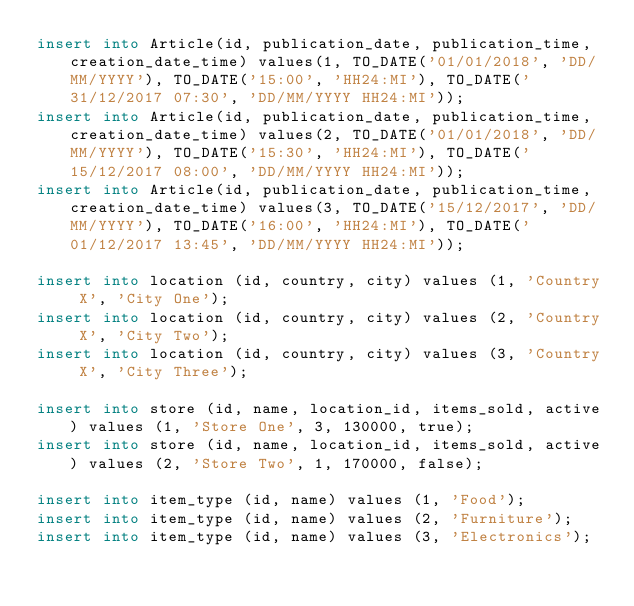<code> <loc_0><loc_0><loc_500><loc_500><_SQL_>insert into Article(id, publication_date, publication_time, creation_date_time) values(1, TO_DATE('01/01/2018', 'DD/MM/YYYY'), TO_DATE('15:00', 'HH24:MI'), TO_DATE('31/12/2017 07:30', 'DD/MM/YYYY HH24:MI'));
insert into Article(id, publication_date, publication_time, creation_date_time) values(2, TO_DATE('01/01/2018', 'DD/MM/YYYY'), TO_DATE('15:30', 'HH24:MI'), TO_DATE('15/12/2017 08:00', 'DD/MM/YYYY HH24:MI'));
insert into Article(id, publication_date, publication_time, creation_date_time) values(3, TO_DATE('15/12/2017', 'DD/MM/YYYY'), TO_DATE('16:00', 'HH24:MI'), TO_DATE('01/12/2017 13:45', 'DD/MM/YYYY HH24:MI'));

insert into location (id, country, city) values (1, 'Country X', 'City One');
insert into location (id, country, city) values (2, 'Country X', 'City Two');
insert into location (id, country, city) values (3, 'Country X', 'City Three');

insert into store (id, name, location_id, items_sold, active) values (1, 'Store One', 3, 130000, true);
insert into store (id, name, location_id, items_sold, active) values (2, 'Store Two', 1, 170000, false);

insert into item_type (id, name) values (1, 'Food');
insert into item_type (id, name) values (2, 'Furniture');
insert into item_type (id, name) values (3, 'Electronics');
</code> 